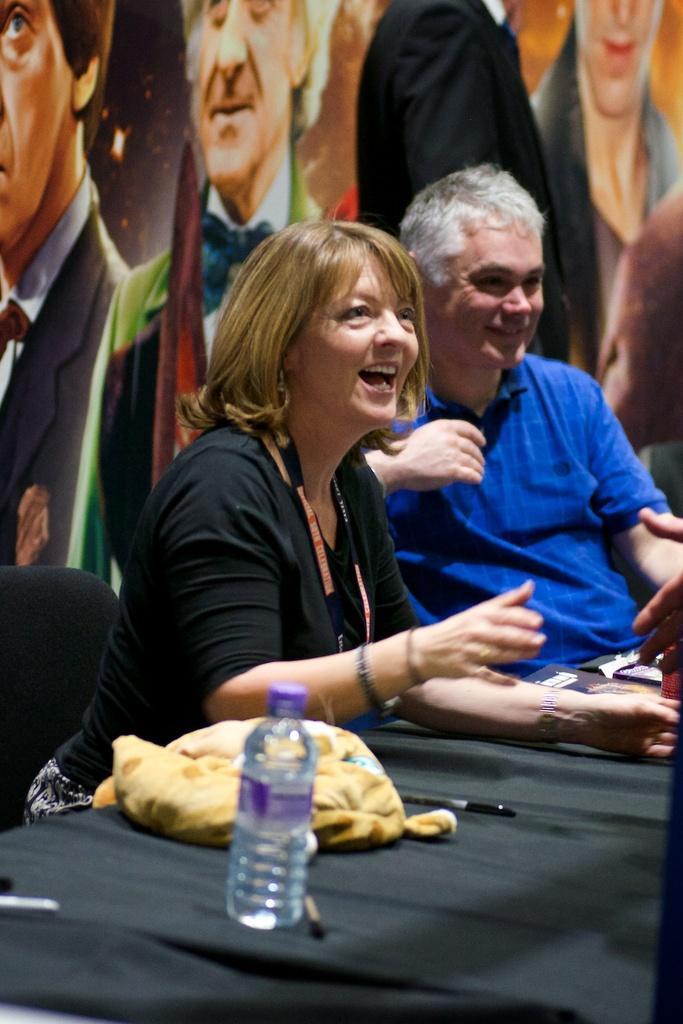Please provide a concise description of this image. In the middle of the image two persons are sitting on a chair. Bottom of the image there is a table, on the table there is a water bottle and there is a bag. At the top of the image there is a banner. 